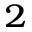Convert formula to latex. <formula><loc_0><loc_0><loc_500><loc_500>_ { 2 }</formula> 